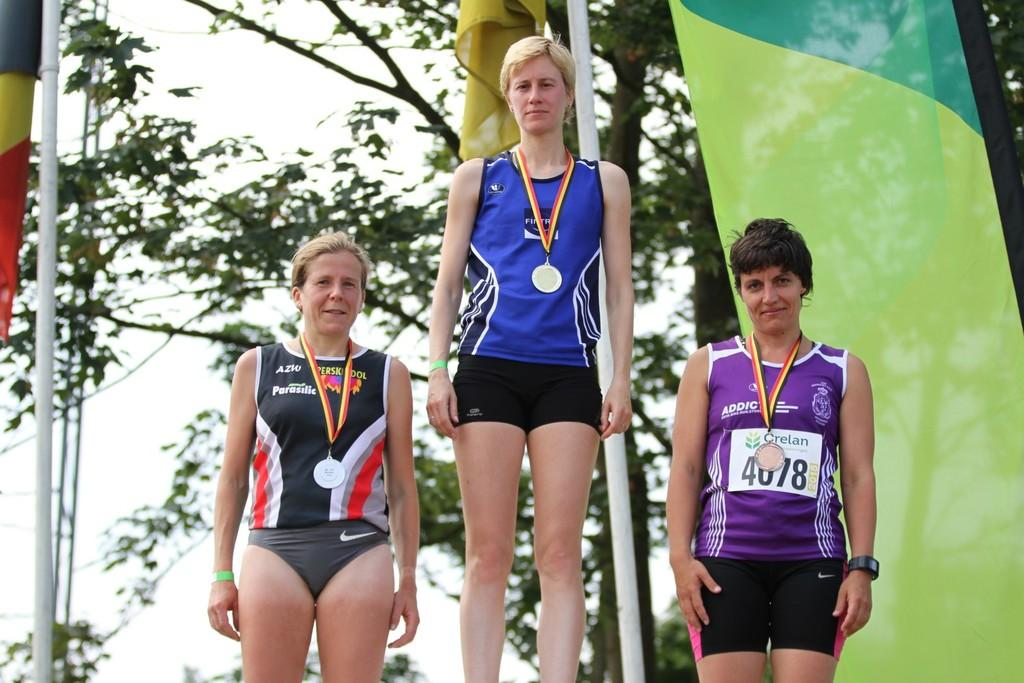<image>
Relay a brief, clear account of the picture shown. AZW logo on a black jersey shirt and a Crelan logo on a purple jersey. 